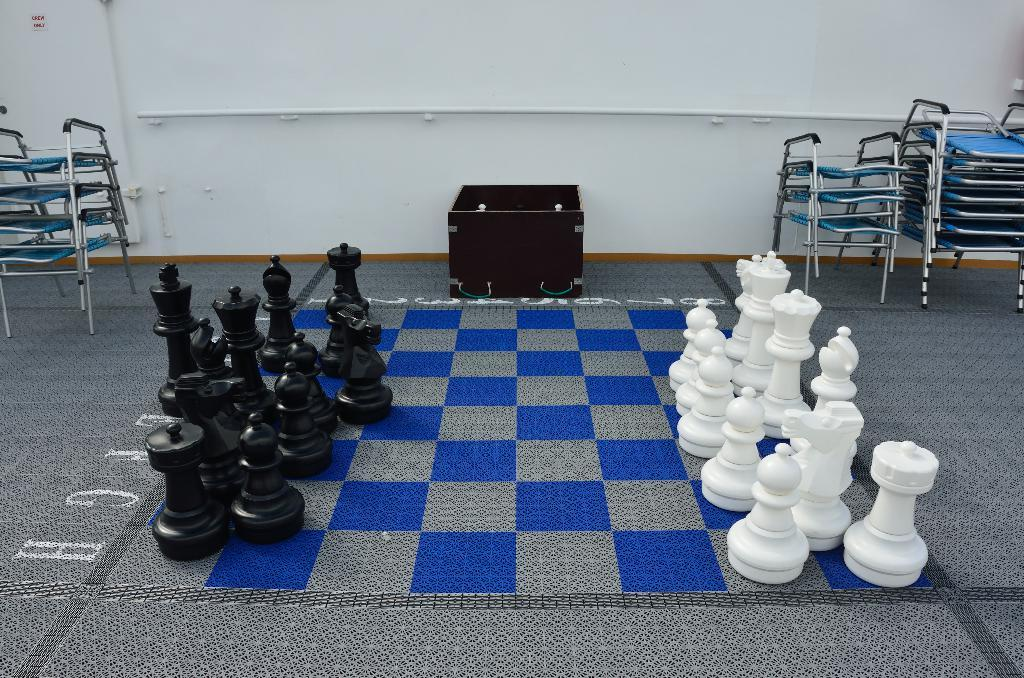What game is being played on the board in the image? There is a chess board in the image, so the game being played is chess. What colors are the chess pieces? The chess pieces are black and white. What object can be seen near the chess board? There is a box in the image. What type of furniture is on the floor in the image? There are chairs on the floor. What is the long, cylindrical object in the image? A pipe is visible in the image. What is in the background of the image? There is a wall in the background of the image. What type of rock can be seen on the chess board in the image? There is no rock present on the chess board in the image; it is a chess board with black and white pieces. What insect is crawling on the pipe in the image? There are no insects visible on the pipe or anywhere else in the image. 